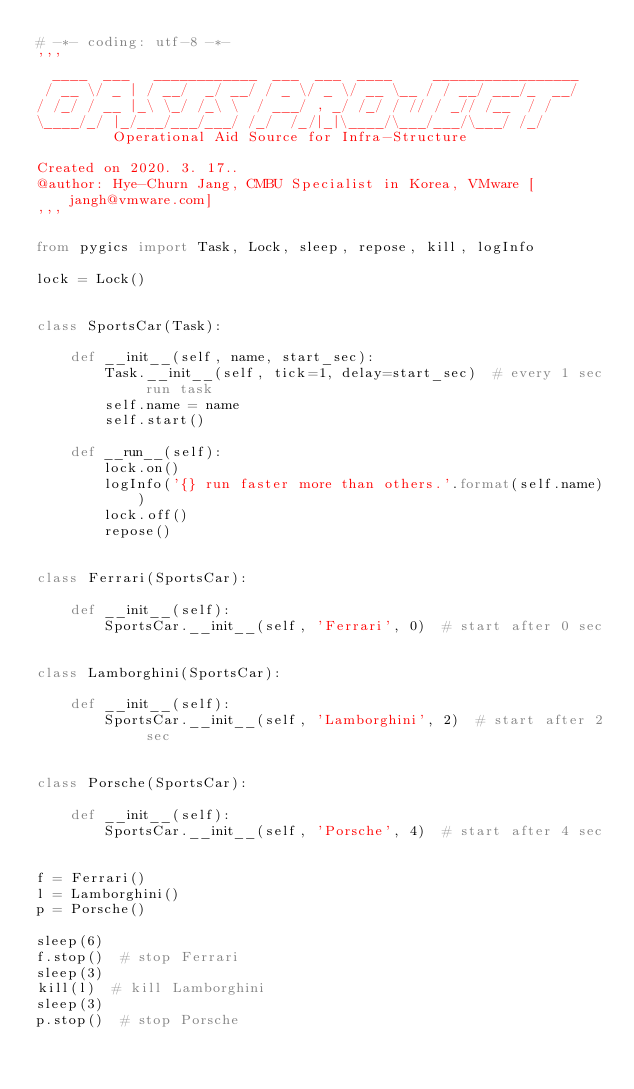<code> <loc_0><loc_0><loc_500><loc_500><_Python_># -*- coding: utf-8 -*-
'''
  ____  ___   ____________  ___  ___  ____     _________________
 / __ \/ _ | / __/  _/ __/ / _ \/ _ \/ __ \__ / / __/ ___/_  __/
/ /_/ / __ |_\ \_/ /_\ \  / ___/ , _/ /_/ / // / _// /__  / /   
\____/_/ |_/___/___/___/ /_/  /_/|_|\____/\___/___/\___/ /_/    
         Operational Aid Source for Infra-Structure 

Created on 2020. 3. 17..
@author: Hye-Churn Jang, CMBU Specialist in Korea, VMware [jangh@vmware.com]
'''

from pygics import Task, Lock, sleep, repose, kill, logInfo

lock = Lock()


class SportsCar(Task):
    
    def __init__(self, name, start_sec):
        Task.__init__(self, tick=1, delay=start_sec)  # every 1 sec run task
        self.name = name
        self.start()
    
    def __run__(self):
        lock.on()
        logInfo('{} run faster more than others.'.format(self.name))
        lock.off()
        repose()


class Ferrari(SportsCar):
    
    def __init__(self):
        SportsCar.__init__(self, 'Ferrari', 0)  # start after 0 sec


class Lamborghini(SportsCar):
    
    def __init__(self):
        SportsCar.__init__(self, 'Lamborghini', 2)  # start after 2 sec


class Porsche(SportsCar):
    
    def __init__(self):
        SportsCar.__init__(self, 'Porsche', 4)  # start after 4 sec


f = Ferrari()
l = Lamborghini()
p = Porsche()

sleep(6)
f.stop()  # stop Ferrari
sleep(3)
kill(l)  # kill Lamborghini
sleep(3)
p.stop()  # stop Porsche
</code> 